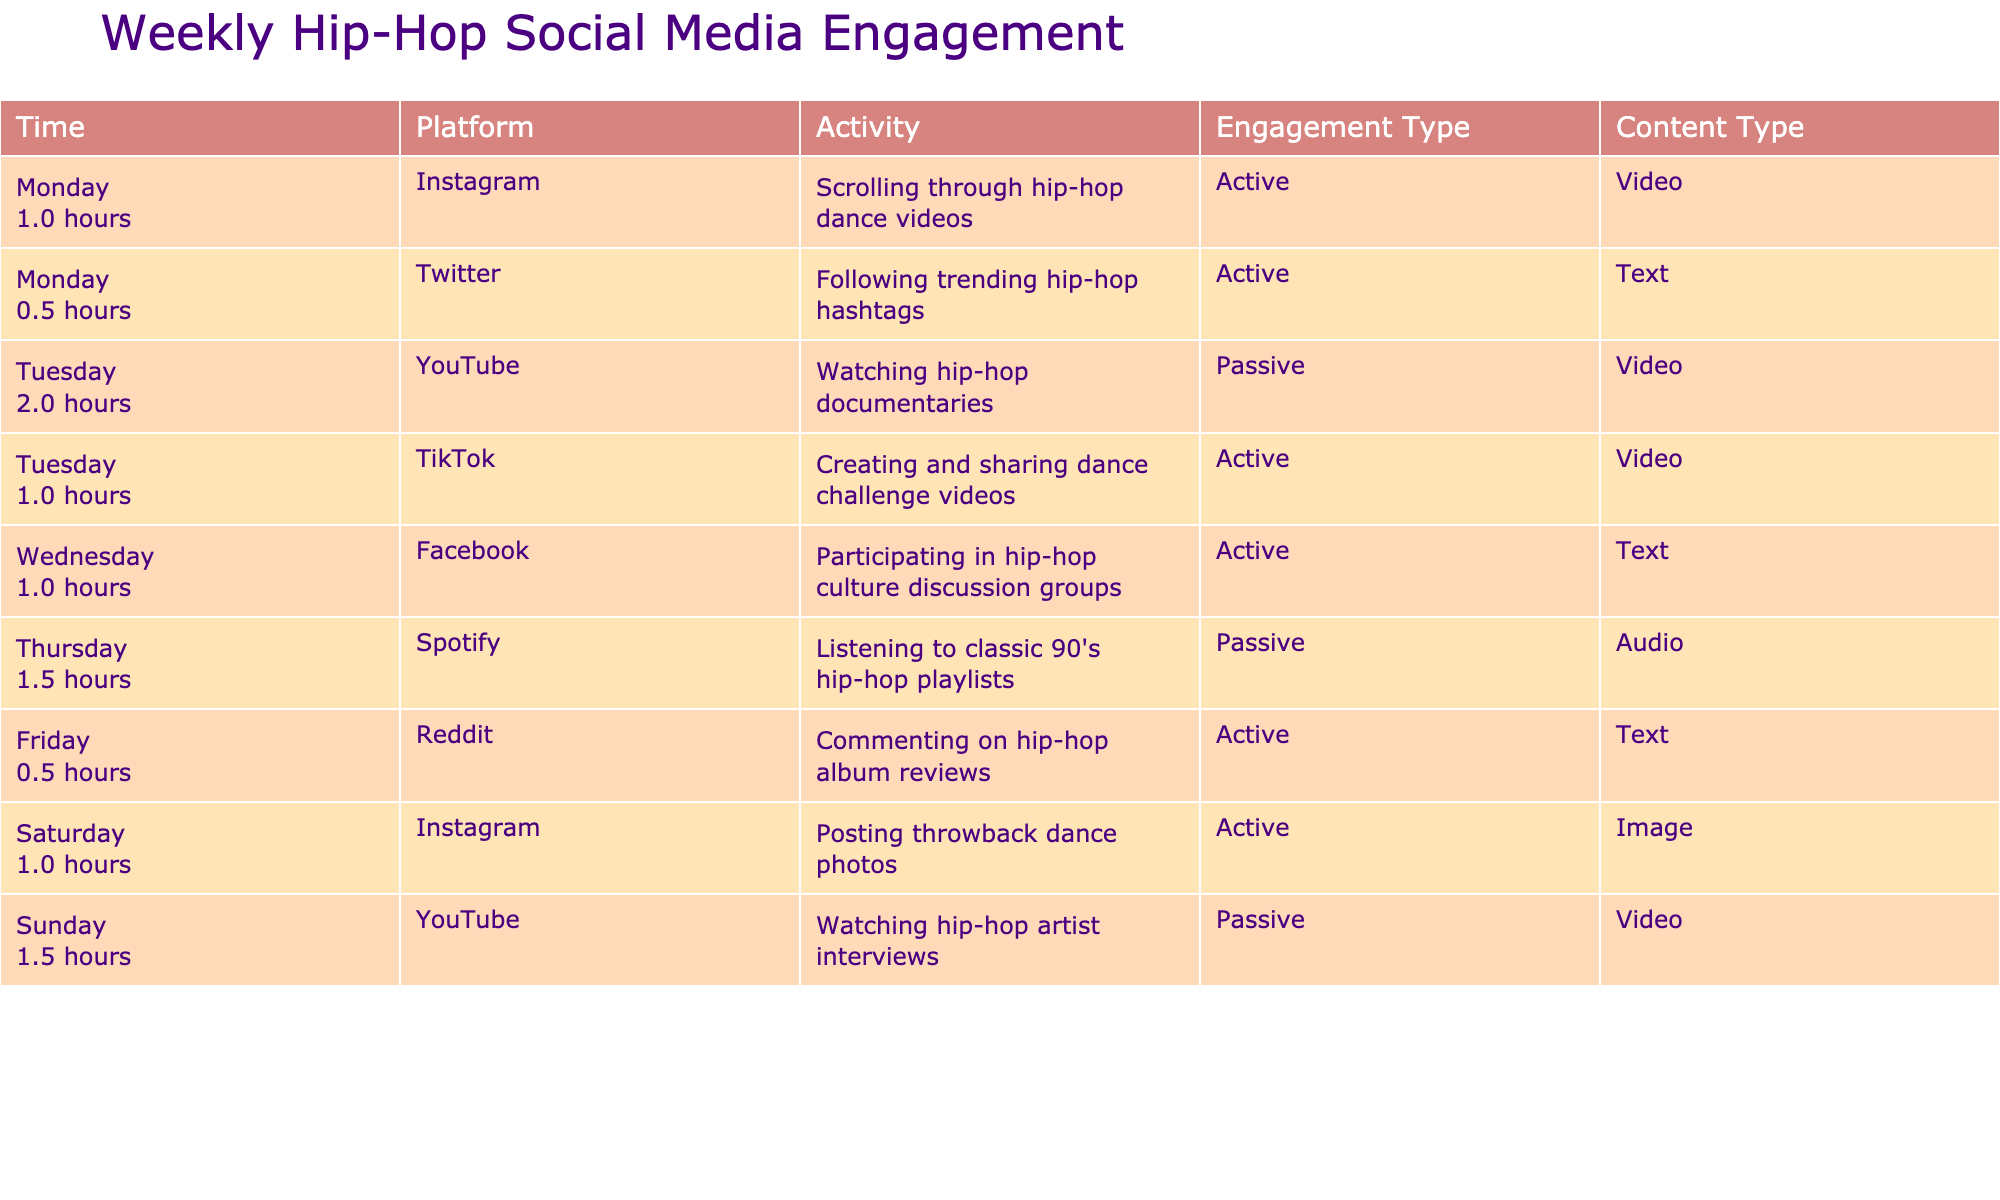What social media platform is used for following trending hip-hop hashtags? Referring to the table, the platform for following trending hip-hop hashtags is Twitter, as specified in the row for Monday.
Answer: Twitter How many hours are spent on Instagram throughout the week? To find the total hours spent on Instagram, we add the hours from the two entries for Instagram: 1 hour (scrolling through dance videos) + 1 hour (posting throwback dance photos) = 2 hours.
Answer: 2 hours Which day has the highest total engagement time, and what is it? We analyze the time spent each day: Monday 1.5 hours, Tuesday 3 hours, Wednesday 1 hour, Thursday 1.5 hours, Friday 0.5 hours, Saturday 1 hour, Sunday 1.5 hours. The highest total is on Tuesday with 3 hours.
Answer: Tuesday, 3 hours Is the engagement type for watching hip-hop documentaries passive? Referring to the entry for Tuesday's YouTube activity, the engagement type is listed as passive.
Answer: Yes How does the total time spent on YouTube compare to the total time spent on TikTok? First, we sum the time for YouTube: 2 hours (watching documentaries) + 1.5 hours (watching artist interviews) = 3.5 hours. For TikTok, the time is 1 hour (creating dance challenge videos). Therefore, 3.5 hours (YouTube) is greater than 1 hour (TikTok).
Answer: 3.5 hours is greater What type of content did you engage with most actively on YouTube this week? From the table, both activities on YouTube (watching hip-hop documentaries and artist interviews) are video content types, making video the most engaged content type on YouTube.
Answer: Video Which activity has the least amount of time spent and what is it? Looking through the table, the activity with the least time is commenting on hip-hop album reviews on Friday, which took 0.5 hours.
Answer: Commenting on album reviews, 0.5 hours How many unique platforms were engaged with throughout the week? Counting the distinct platforms listed in the table: Instagram, Twitter, YouTube, TikTok, Facebook, Spotify, Reddit, results in a total of 7 unique platforms.
Answer: 7 platforms Was there any engagement activity that involved listening to music? The activities involving listening to music include listening to classic 90's hip-hop playlists on Spotify on Thursday, which indicates there was at least one such activity.
Answer: Yes 